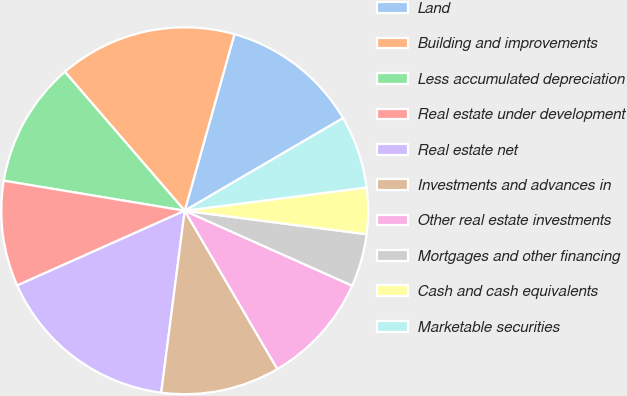Convert chart to OTSL. <chart><loc_0><loc_0><loc_500><loc_500><pie_chart><fcel>Land<fcel>Building and improvements<fcel>Less accumulated depreciation<fcel>Real estate under development<fcel>Real estate net<fcel>Investments and advances in<fcel>Other real estate investments<fcel>Mortgages and other financing<fcel>Cash and cash equivalents<fcel>Marketable securities<nl><fcel>12.21%<fcel>15.7%<fcel>11.05%<fcel>9.3%<fcel>16.28%<fcel>10.47%<fcel>9.88%<fcel>4.65%<fcel>4.07%<fcel>6.4%<nl></chart> 